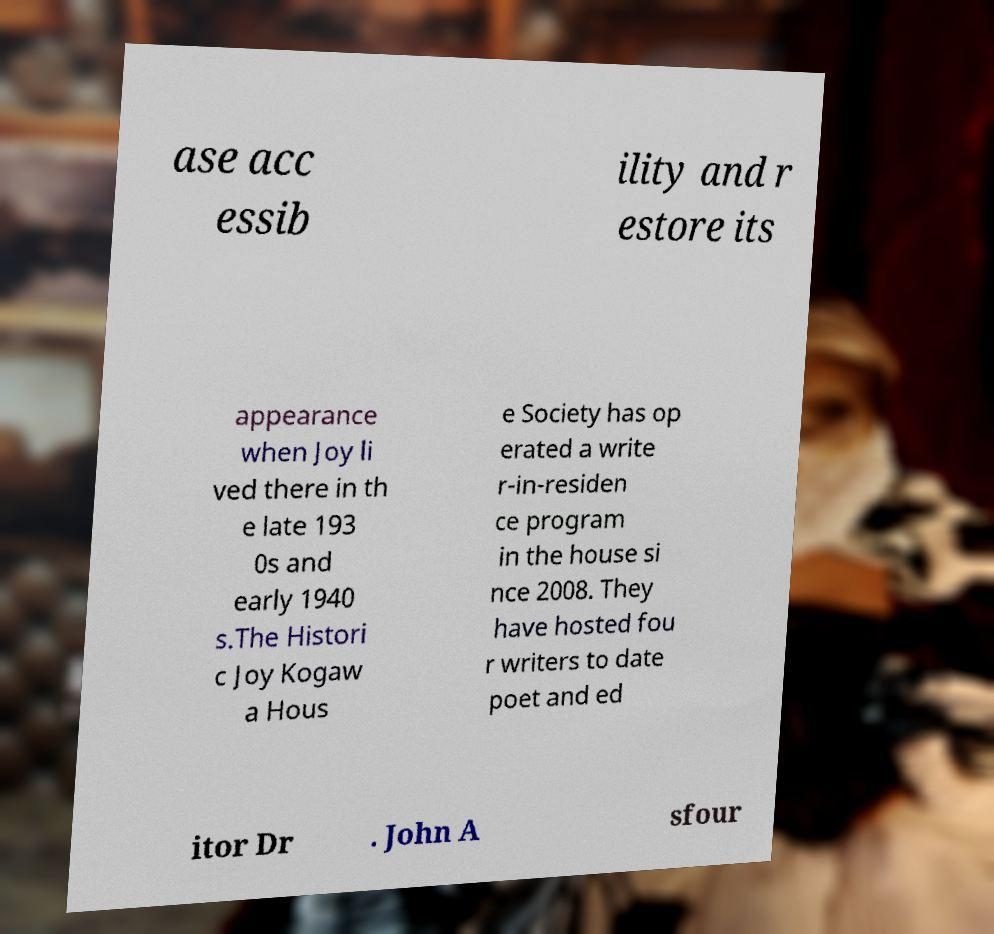Please identify and transcribe the text found in this image. ase acc essib ility and r estore its appearance when Joy li ved there in th e late 193 0s and early 1940 s.The Histori c Joy Kogaw a Hous e Society has op erated a write r-in-residen ce program in the house si nce 2008. They have hosted fou r writers to date poet and ed itor Dr . John A sfour 